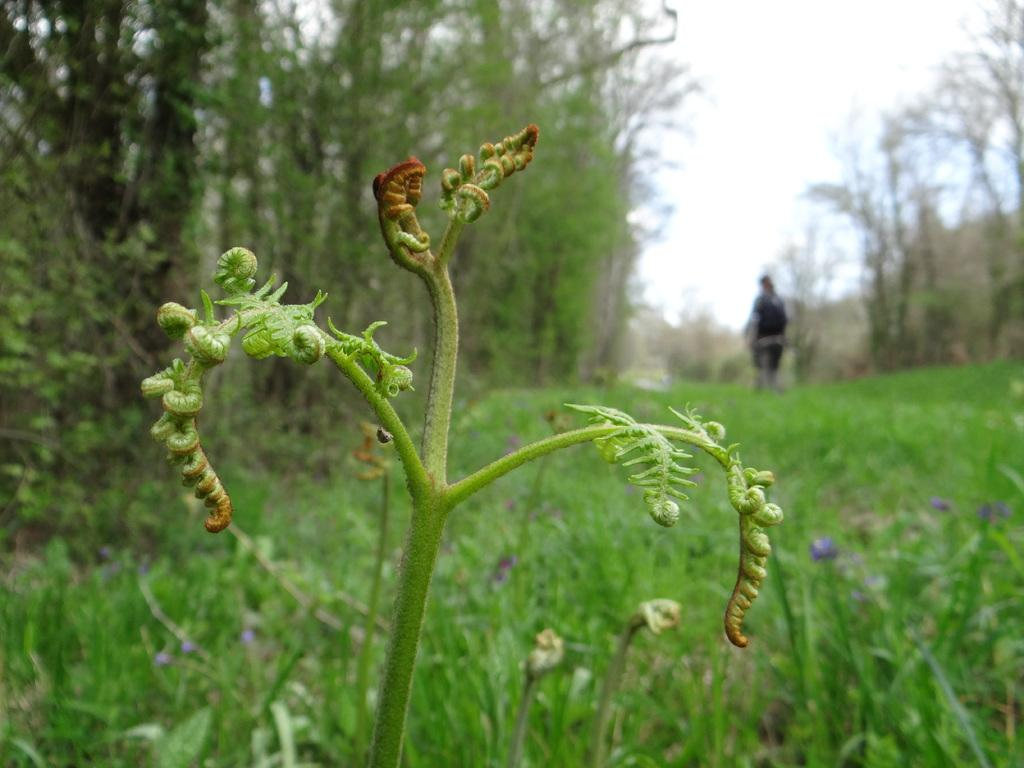What type of living organisms can be seen in the image? Plants can be seen in the image. What can be seen in the background of the image? There are trees and a person in the background of the image. What part of the natural environment is visible in the image? The sky is visible in the background of the image. What number is written on the mailbox in the image? There is no mailbox present in the image. What type of body is visible in the image? There is no body present in the image; only plants, trees, a person, and the sky are visible. 